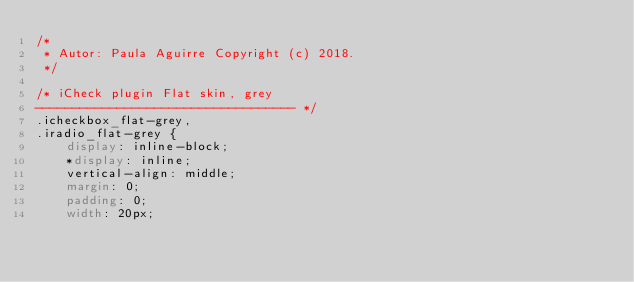Convert code to text. <code><loc_0><loc_0><loc_500><loc_500><_CSS_>/*
 * Autor: Paula Aguirre Copyright (c) 2018.
 */

/* iCheck plugin Flat skin, grey
----------------------------------- */
.icheckbox_flat-grey,
.iradio_flat-grey {
    display: inline-block;
    *display: inline;
    vertical-align: middle;
    margin: 0;
    padding: 0;
    width: 20px;</code> 